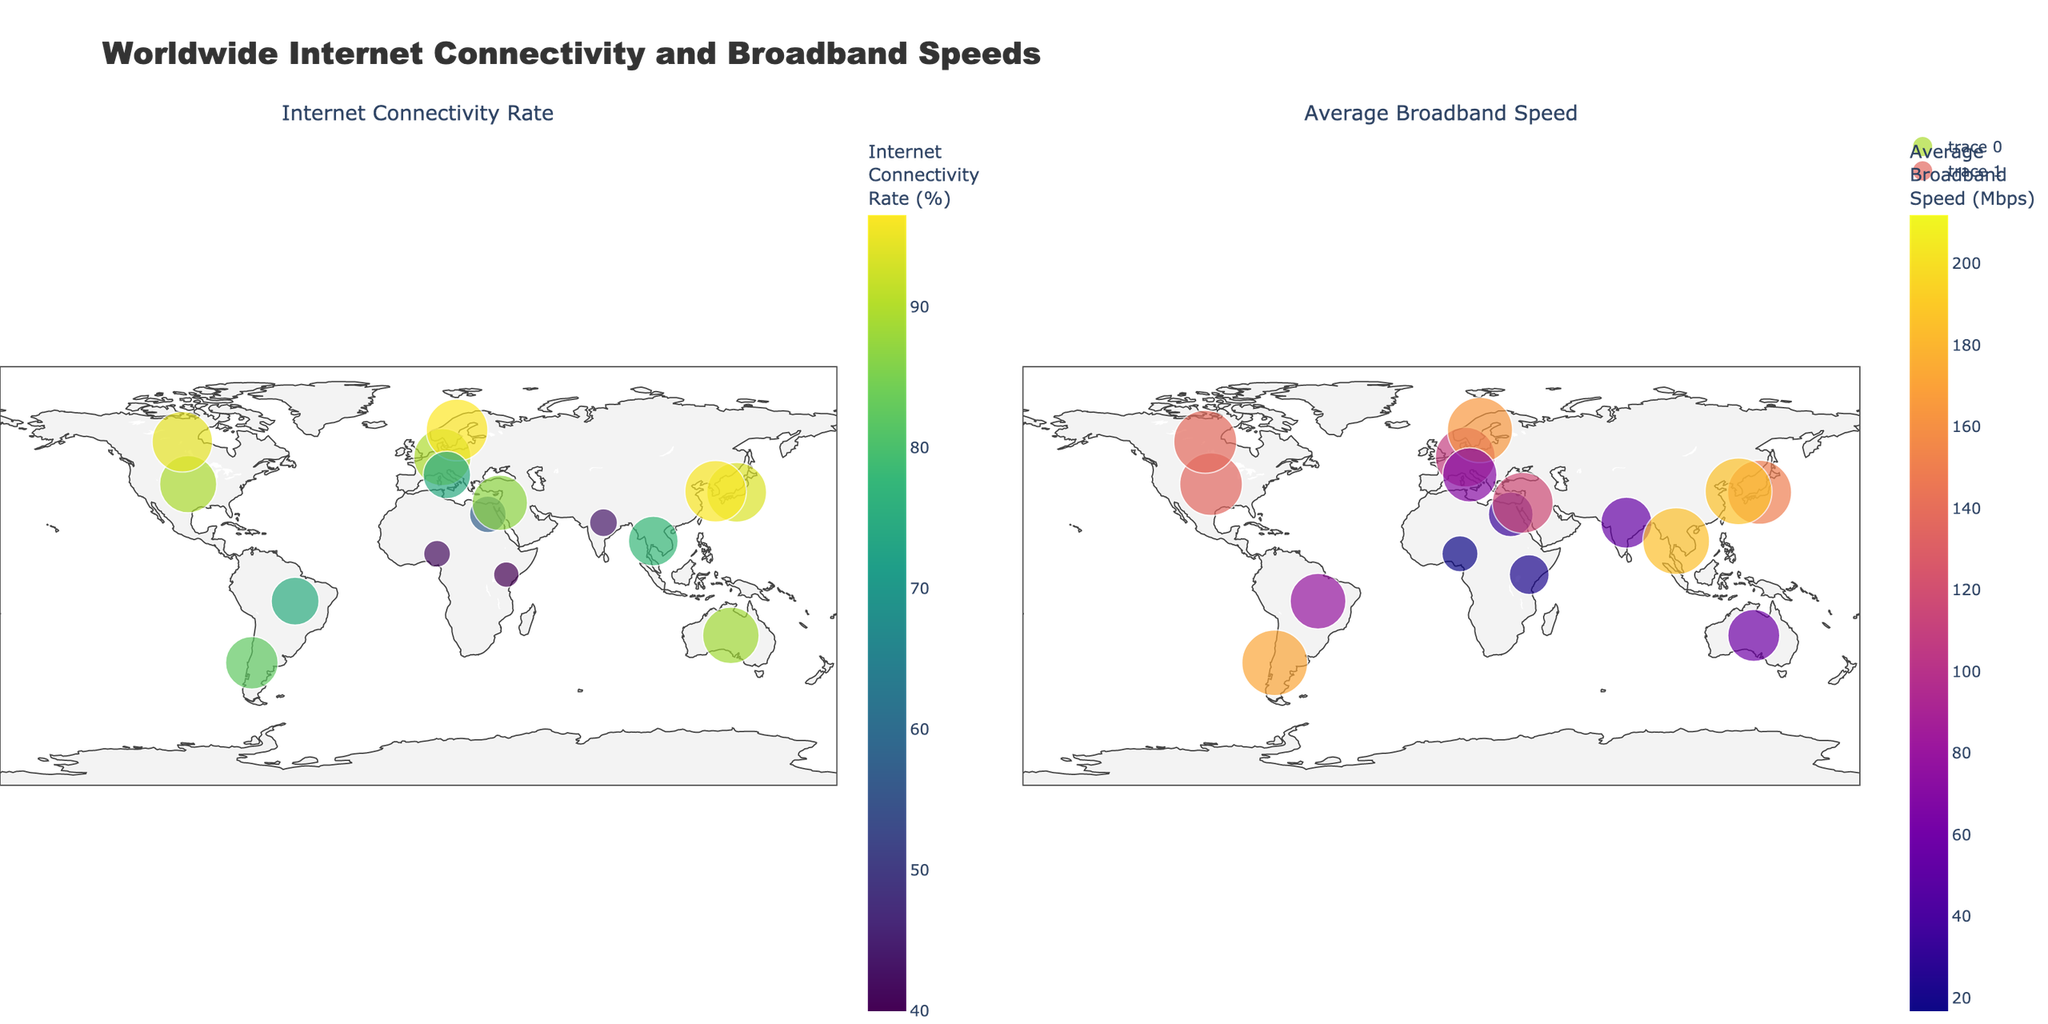What's the title of the figure? The title is prominently displayed at the top center of the figure.
Answer: Worldwide Internet Connectivity and Broadband Speeds How many subplots are present in the figure? The figure is divided into two sections, each representing different metrics.
Answer: Two subplots Which country has the highest internet connectivity rate? The first subplot uses color intensity and size to represent the internet connectivity rate. The brightest and largest marker corresponds to Sweden.
Answer: Sweden Which country shows the lowest average broadband speed? The second subplot uses color intensity and size to represent average broadband speed. The smallest and least intense marker corresponds to Nigeria.
Answer: Nigeria What is the internet connectivity rate of India? By locating India in the first subplot, we can see the size and color intensity corresponding to India. Hover over to reveal the exact percentage.
Answer: 43.7% Are there any countries with an internet connectivity rate above 95%? Which ones? From the first subplot, the countries with the highest color intensity and largest sizes denote >95% rates. Hovering over them, we identify South Korea and Sweden.
Answer: South Korea and Sweden How does the average broadband speed of Japan compare to that of the United States? By examining the size and color intensity of Japan and the United States in the second subplot, Japan appears to have a slightly larger and more intense marker. The exact speeds are revealed on hover.
Answer: Japan: 149.8 Mbps, United States: 135.2 Mbps Which country has the largest difference between internet connectivity rate and average broadband speed? First, we should look for larger discrepancies between marker sizes and color intensities across the two subplots. Calculating exact differences can be done by hovering over each country: (South Korea - 96.2% connectivity, 186.1 Mbps speed).
Answer: South Korea Do notably high connectivity rates always correspond to high broadband speeds? Check various countries in both subplots to see if high internet connectivity rates (left) consistently show high broadband speeds (right). For example, South Korea and Sweden fit, but not all do.
Answer: Not always 